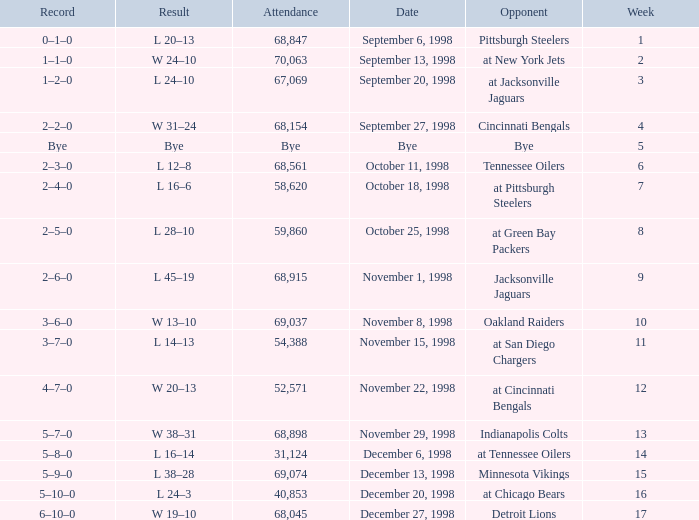What is the highest week that was played against the Minnesota Vikings? 15.0. 